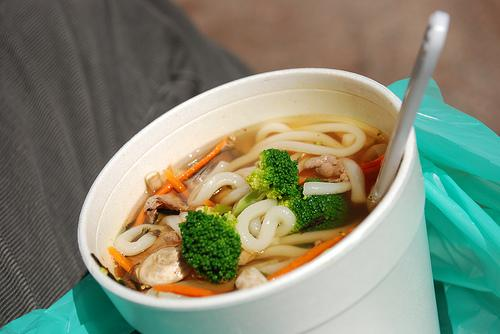Question: why was this taken?
Choices:
A. Perspective.
B. To document the moment.
C. For sentimental reasons.
D. For a police mugshot.
Answer with the letter. Answer: A Question: how was this taken?
Choices:
A. Painted.
B. Collage with bits of paper.
C. Crayoned.
D. A camera.
Answer with the letter. Answer: D Question: where was this taken?
Choices:
A. A street fair.
B. An office.
C. A restaurant.
D. A school.
Answer with the letter. Answer: C Question: what is the color of the persons shirt?
Choices:
A. Grey.
B. White.
C. Yellow.
D. Red.
Answer with the letter. Answer: A 